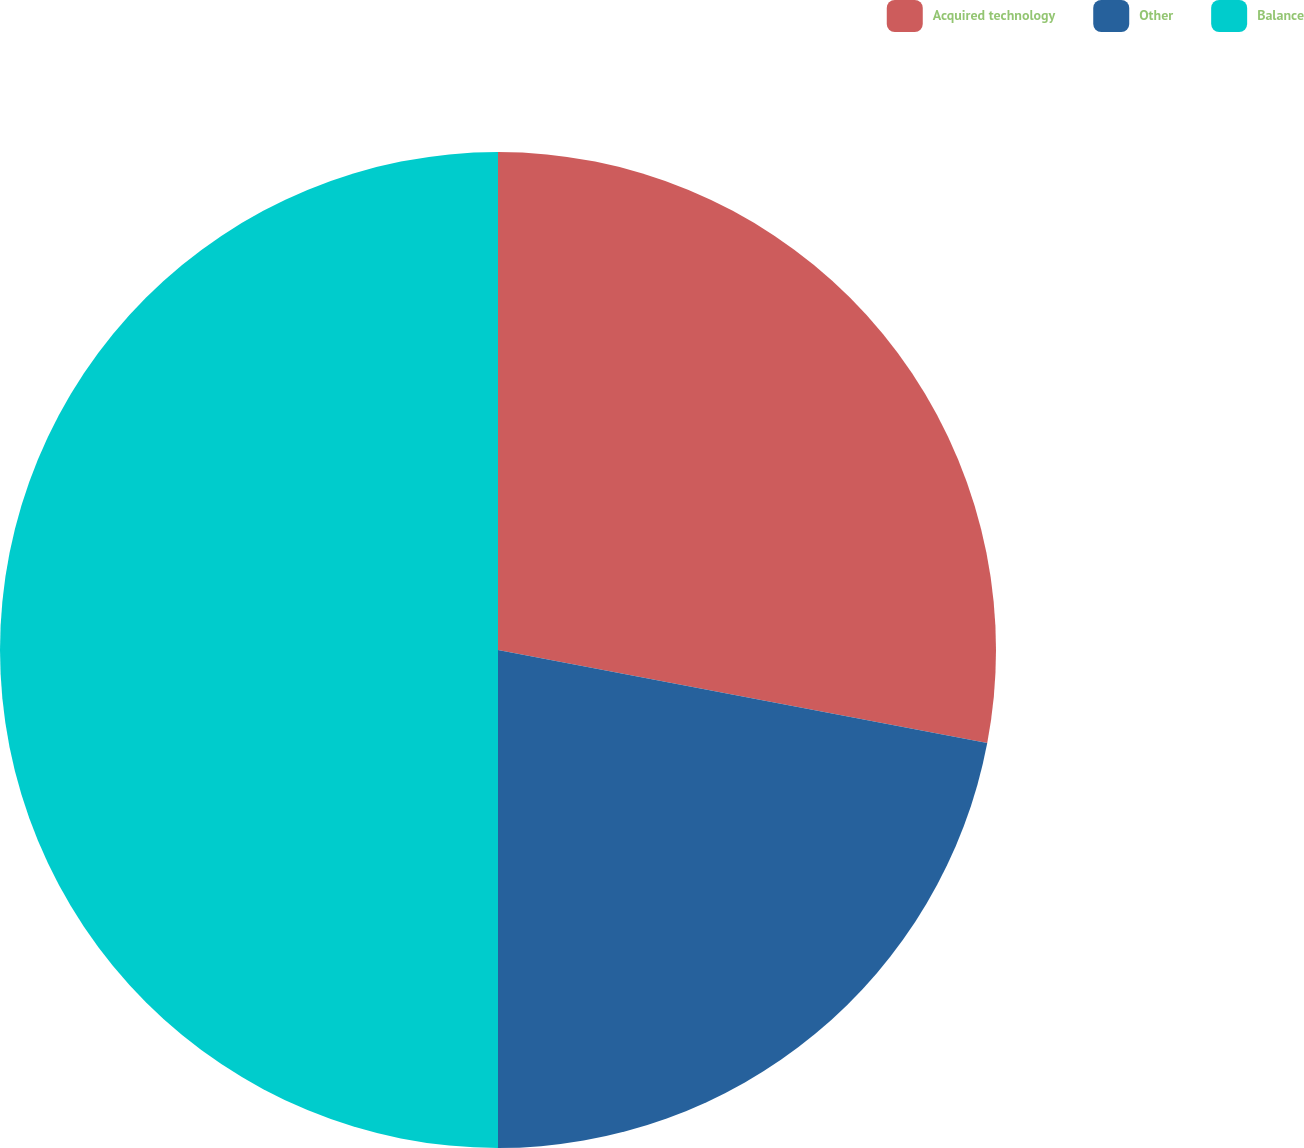<chart> <loc_0><loc_0><loc_500><loc_500><pie_chart><fcel>Acquired technology<fcel>Other<fcel>Balance<nl><fcel>27.99%<fcel>22.01%<fcel>50.0%<nl></chart> 